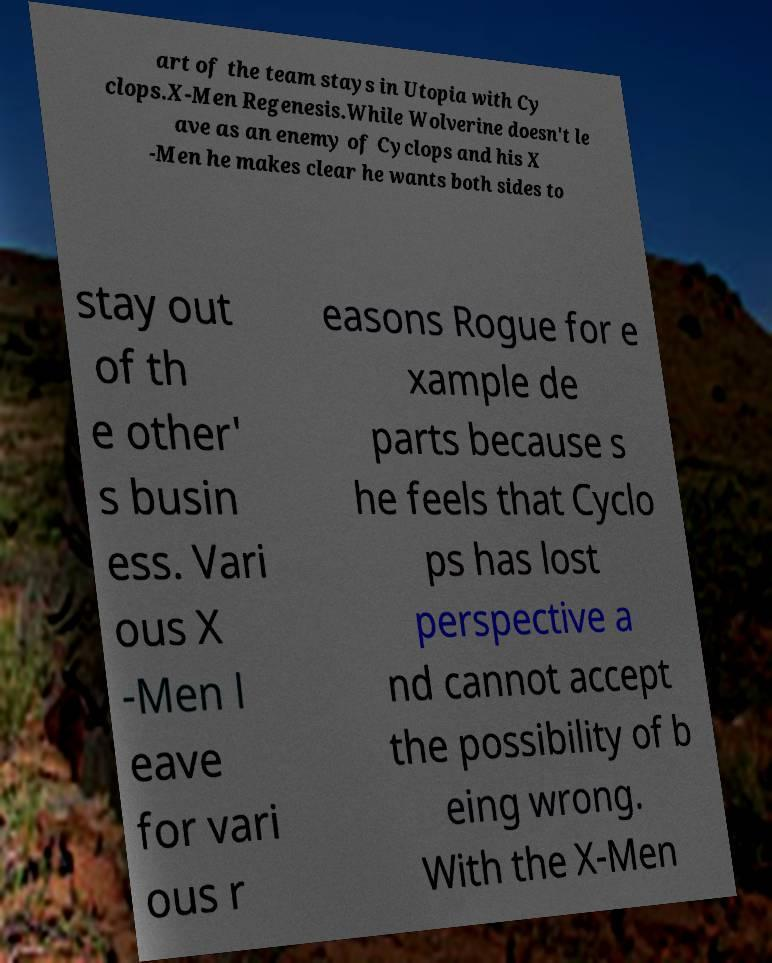Please read and relay the text visible in this image. What does it say? art of the team stays in Utopia with Cy clops.X-Men Regenesis.While Wolverine doesn't le ave as an enemy of Cyclops and his X -Men he makes clear he wants both sides to stay out of th e other' s busin ess. Vari ous X -Men l eave for vari ous r easons Rogue for e xample de parts because s he feels that Cyclo ps has lost perspective a nd cannot accept the possibility of b eing wrong. With the X-Men 